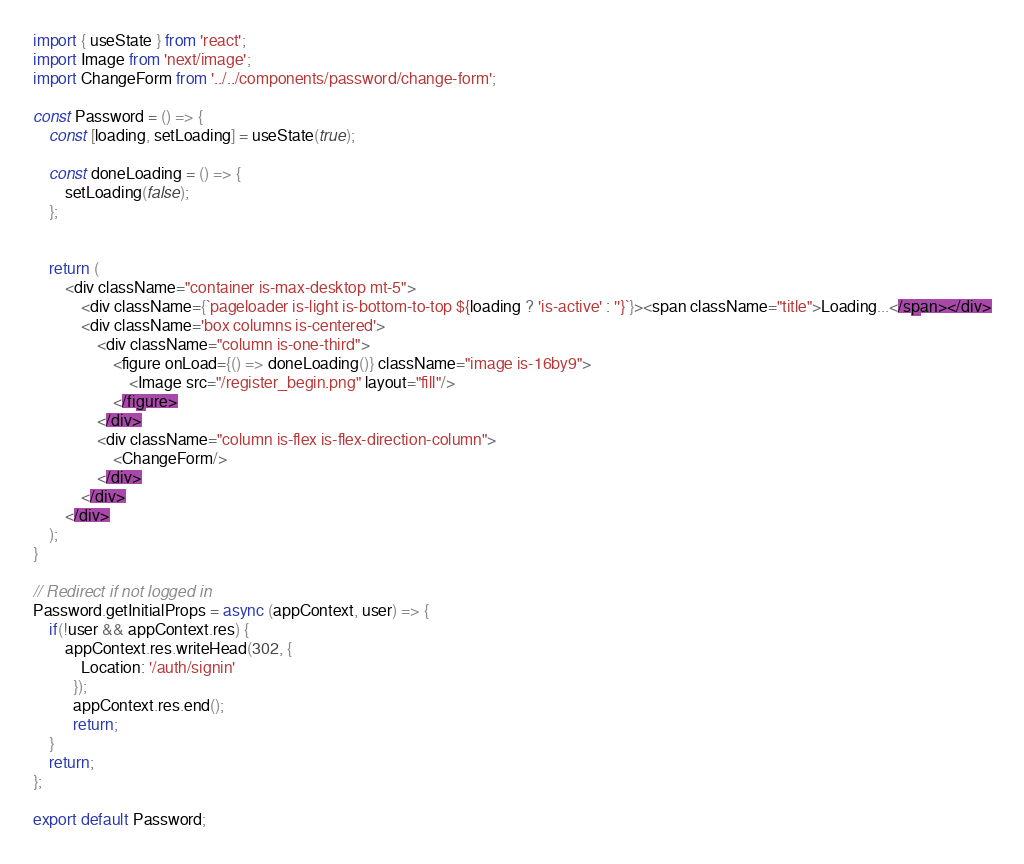Convert code to text. <code><loc_0><loc_0><loc_500><loc_500><_JavaScript_>import { useState } from 'react';
import Image from 'next/image';
import ChangeForm from '../../components/password/change-form';

const Password = () => {
    const [loading, setLoading] = useState(true);

    const doneLoading = () => {
        setLoading(false);
    };


    return (
        <div className="container is-max-desktop mt-5">
            <div className={`pageloader is-light is-bottom-to-top ${loading ? 'is-active' : ''}`}><span className="title">Loading...</span></div>
            <div className='box columns is-centered'>
                <div className="column is-one-third"> 
                    <figure onLoad={() => doneLoading()} className="image is-16by9">
                        <Image src="/register_begin.png" layout="fill"/>
                    </figure>
                </div>
                <div className="column is-flex is-flex-direction-column">
                    <ChangeForm/>
                </div>
            </div>
        </div>
    );
}

// Redirect if not logged in
Password.getInitialProps = async (appContext, user) => {
    if(!user && appContext.res) {
        appContext.res.writeHead(302, {
            Location: '/auth/signin'
          });
          appContext.res.end();
          return;
    }
    return;
};

export default Password;</code> 